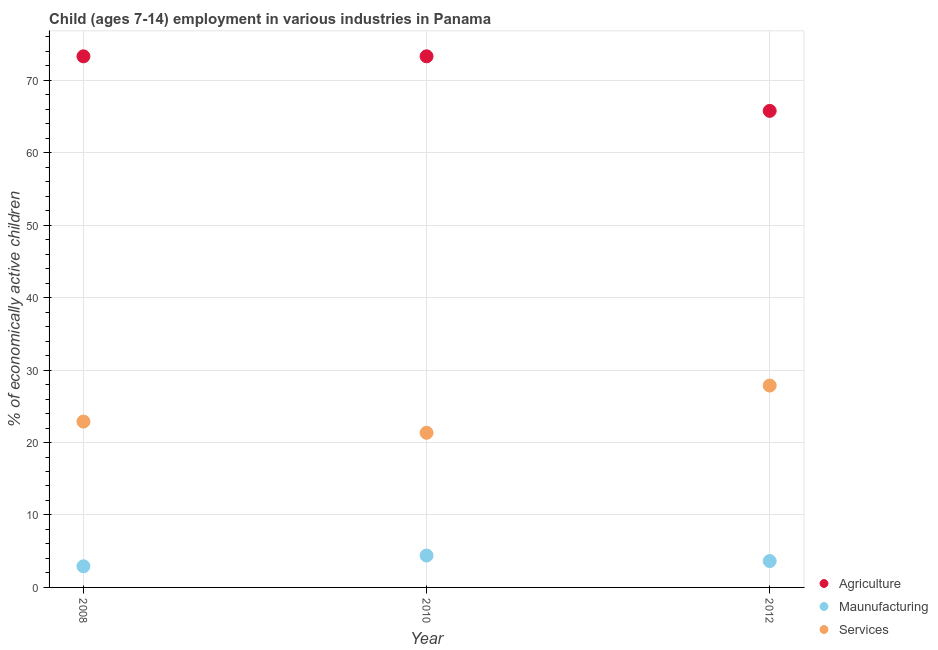What is the percentage of economically active children in agriculture in 2012?
Offer a very short reply. 65.77. Across all years, what is the maximum percentage of economically active children in agriculture?
Your response must be concise. 73.3. Across all years, what is the minimum percentage of economically active children in agriculture?
Give a very brief answer. 65.77. What is the total percentage of economically active children in agriculture in the graph?
Keep it short and to the point. 212.37. What is the difference between the percentage of economically active children in manufacturing in 2008 and that in 2012?
Provide a short and direct response. -0.72. What is the difference between the percentage of economically active children in agriculture in 2010 and the percentage of economically active children in manufacturing in 2008?
Keep it short and to the point. 70.38. What is the average percentage of economically active children in manufacturing per year?
Your answer should be compact. 3.65. In the year 2010, what is the difference between the percentage of economically active children in agriculture and percentage of economically active children in manufacturing?
Your response must be concise. 68.9. Is the percentage of economically active children in services in 2010 less than that in 2012?
Your answer should be compact. Yes. Is the difference between the percentage of economically active children in services in 2008 and 2010 greater than the difference between the percentage of economically active children in manufacturing in 2008 and 2010?
Offer a very short reply. Yes. What is the difference between the highest and the second highest percentage of economically active children in services?
Ensure brevity in your answer.  4.97. What is the difference between the highest and the lowest percentage of economically active children in manufacturing?
Your answer should be very brief. 1.48. Is the sum of the percentage of economically active children in manufacturing in 2010 and 2012 greater than the maximum percentage of economically active children in services across all years?
Your answer should be compact. No. Is it the case that in every year, the sum of the percentage of economically active children in agriculture and percentage of economically active children in manufacturing is greater than the percentage of economically active children in services?
Offer a very short reply. Yes. Does the percentage of economically active children in services monotonically increase over the years?
Offer a terse response. No. Is the percentage of economically active children in services strictly less than the percentage of economically active children in agriculture over the years?
Provide a short and direct response. Yes. How many dotlines are there?
Your answer should be very brief. 3. Does the graph contain grids?
Offer a terse response. Yes. How many legend labels are there?
Ensure brevity in your answer.  3. How are the legend labels stacked?
Provide a succinct answer. Vertical. What is the title of the graph?
Ensure brevity in your answer.  Child (ages 7-14) employment in various industries in Panama. What is the label or title of the X-axis?
Offer a very short reply. Year. What is the label or title of the Y-axis?
Your answer should be very brief. % of economically active children. What is the % of economically active children of Agriculture in 2008?
Give a very brief answer. 73.3. What is the % of economically active children in Maunufacturing in 2008?
Make the answer very short. 2.92. What is the % of economically active children in Services in 2008?
Keep it short and to the point. 22.89. What is the % of economically active children in Agriculture in 2010?
Give a very brief answer. 73.3. What is the % of economically active children in Maunufacturing in 2010?
Keep it short and to the point. 4.4. What is the % of economically active children of Services in 2010?
Provide a succinct answer. 21.34. What is the % of economically active children of Agriculture in 2012?
Offer a terse response. 65.77. What is the % of economically active children in Maunufacturing in 2012?
Offer a very short reply. 3.64. What is the % of economically active children in Services in 2012?
Make the answer very short. 27.86. Across all years, what is the maximum % of economically active children of Agriculture?
Offer a very short reply. 73.3. Across all years, what is the maximum % of economically active children in Maunufacturing?
Offer a very short reply. 4.4. Across all years, what is the maximum % of economically active children in Services?
Keep it short and to the point. 27.86. Across all years, what is the minimum % of economically active children of Agriculture?
Provide a succinct answer. 65.77. Across all years, what is the minimum % of economically active children in Maunufacturing?
Keep it short and to the point. 2.92. Across all years, what is the minimum % of economically active children of Services?
Ensure brevity in your answer.  21.34. What is the total % of economically active children of Agriculture in the graph?
Give a very brief answer. 212.37. What is the total % of economically active children in Maunufacturing in the graph?
Your answer should be compact. 10.96. What is the total % of economically active children in Services in the graph?
Offer a terse response. 72.09. What is the difference between the % of economically active children in Maunufacturing in 2008 and that in 2010?
Your answer should be compact. -1.48. What is the difference between the % of economically active children in Services in 2008 and that in 2010?
Ensure brevity in your answer.  1.55. What is the difference between the % of economically active children in Agriculture in 2008 and that in 2012?
Offer a very short reply. 7.53. What is the difference between the % of economically active children in Maunufacturing in 2008 and that in 2012?
Ensure brevity in your answer.  -0.72. What is the difference between the % of economically active children of Services in 2008 and that in 2012?
Offer a terse response. -4.97. What is the difference between the % of economically active children of Agriculture in 2010 and that in 2012?
Offer a terse response. 7.53. What is the difference between the % of economically active children in Maunufacturing in 2010 and that in 2012?
Provide a succinct answer. 0.76. What is the difference between the % of economically active children of Services in 2010 and that in 2012?
Make the answer very short. -6.52. What is the difference between the % of economically active children in Agriculture in 2008 and the % of economically active children in Maunufacturing in 2010?
Offer a very short reply. 68.9. What is the difference between the % of economically active children of Agriculture in 2008 and the % of economically active children of Services in 2010?
Your answer should be very brief. 51.96. What is the difference between the % of economically active children in Maunufacturing in 2008 and the % of economically active children in Services in 2010?
Your answer should be compact. -18.42. What is the difference between the % of economically active children of Agriculture in 2008 and the % of economically active children of Maunufacturing in 2012?
Your answer should be very brief. 69.66. What is the difference between the % of economically active children of Agriculture in 2008 and the % of economically active children of Services in 2012?
Your answer should be compact. 45.44. What is the difference between the % of economically active children of Maunufacturing in 2008 and the % of economically active children of Services in 2012?
Your answer should be compact. -24.94. What is the difference between the % of economically active children of Agriculture in 2010 and the % of economically active children of Maunufacturing in 2012?
Offer a very short reply. 69.66. What is the difference between the % of economically active children in Agriculture in 2010 and the % of economically active children in Services in 2012?
Your answer should be very brief. 45.44. What is the difference between the % of economically active children in Maunufacturing in 2010 and the % of economically active children in Services in 2012?
Keep it short and to the point. -23.46. What is the average % of economically active children in Agriculture per year?
Give a very brief answer. 70.79. What is the average % of economically active children of Maunufacturing per year?
Your answer should be very brief. 3.65. What is the average % of economically active children in Services per year?
Your response must be concise. 24.03. In the year 2008, what is the difference between the % of economically active children of Agriculture and % of economically active children of Maunufacturing?
Keep it short and to the point. 70.38. In the year 2008, what is the difference between the % of economically active children in Agriculture and % of economically active children in Services?
Offer a terse response. 50.41. In the year 2008, what is the difference between the % of economically active children in Maunufacturing and % of economically active children in Services?
Offer a terse response. -19.97. In the year 2010, what is the difference between the % of economically active children of Agriculture and % of economically active children of Maunufacturing?
Offer a terse response. 68.9. In the year 2010, what is the difference between the % of economically active children of Agriculture and % of economically active children of Services?
Your response must be concise. 51.96. In the year 2010, what is the difference between the % of economically active children of Maunufacturing and % of economically active children of Services?
Offer a terse response. -16.94. In the year 2012, what is the difference between the % of economically active children of Agriculture and % of economically active children of Maunufacturing?
Provide a short and direct response. 62.13. In the year 2012, what is the difference between the % of economically active children in Agriculture and % of economically active children in Services?
Your answer should be very brief. 37.91. In the year 2012, what is the difference between the % of economically active children of Maunufacturing and % of economically active children of Services?
Provide a short and direct response. -24.22. What is the ratio of the % of economically active children of Maunufacturing in 2008 to that in 2010?
Keep it short and to the point. 0.66. What is the ratio of the % of economically active children of Services in 2008 to that in 2010?
Your answer should be very brief. 1.07. What is the ratio of the % of economically active children of Agriculture in 2008 to that in 2012?
Your response must be concise. 1.11. What is the ratio of the % of economically active children of Maunufacturing in 2008 to that in 2012?
Make the answer very short. 0.8. What is the ratio of the % of economically active children in Services in 2008 to that in 2012?
Keep it short and to the point. 0.82. What is the ratio of the % of economically active children in Agriculture in 2010 to that in 2012?
Your answer should be compact. 1.11. What is the ratio of the % of economically active children of Maunufacturing in 2010 to that in 2012?
Your response must be concise. 1.21. What is the ratio of the % of economically active children in Services in 2010 to that in 2012?
Give a very brief answer. 0.77. What is the difference between the highest and the second highest % of economically active children in Agriculture?
Ensure brevity in your answer.  0. What is the difference between the highest and the second highest % of economically active children in Maunufacturing?
Your answer should be very brief. 0.76. What is the difference between the highest and the second highest % of economically active children of Services?
Make the answer very short. 4.97. What is the difference between the highest and the lowest % of economically active children of Agriculture?
Offer a terse response. 7.53. What is the difference between the highest and the lowest % of economically active children in Maunufacturing?
Your response must be concise. 1.48. What is the difference between the highest and the lowest % of economically active children of Services?
Provide a succinct answer. 6.52. 